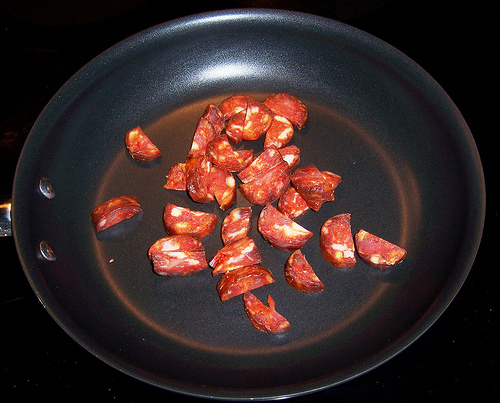<image>
Can you confirm if the dog is next to the car? No. The dog is not positioned next to the car. They are located in different areas of the scene. 